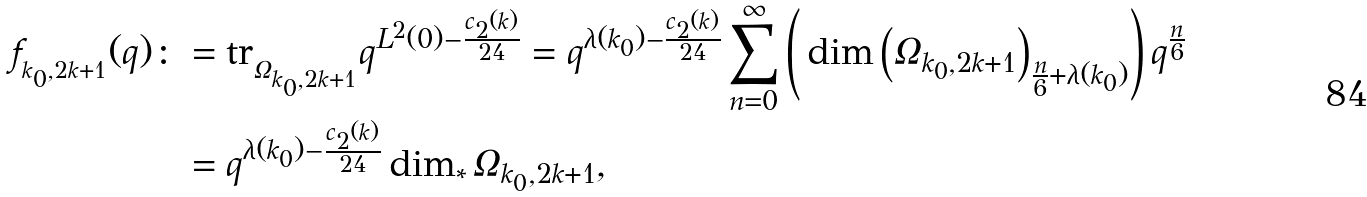Convert formula to latex. <formula><loc_0><loc_0><loc_500><loc_500>f _ { _ { k _ { 0 } , 2 k + 1 } } ( q ) \colon & = \text {tr} _ { _ { \Omega _ { k _ { 0 } , 2 k + 1 } } } q ^ { L ^ { 2 } ( 0 ) - \frac { c _ { 2 } ( k ) } { 2 4 } } = q ^ { \lambda ( k _ { 0 } ) - \frac { c _ { 2 } ( k ) } { 2 4 } } \sum _ { n = 0 } ^ { \infty } \left ( \, \dim \left ( \Omega _ { k _ { 0 } , 2 k + 1 } \right ) _ { \frac { n } { 6 } + \lambda ( k _ { 0 } ) } \right ) q ^ { \frac { n } { 6 } } \\ & = q ^ { \lambda ( k _ { 0 } ) - \frac { c _ { 2 } ( k ) } { 2 4 } } \dim _ { * } \Omega _ { k _ { 0 } , 2 k + 1 } ,</formula> 